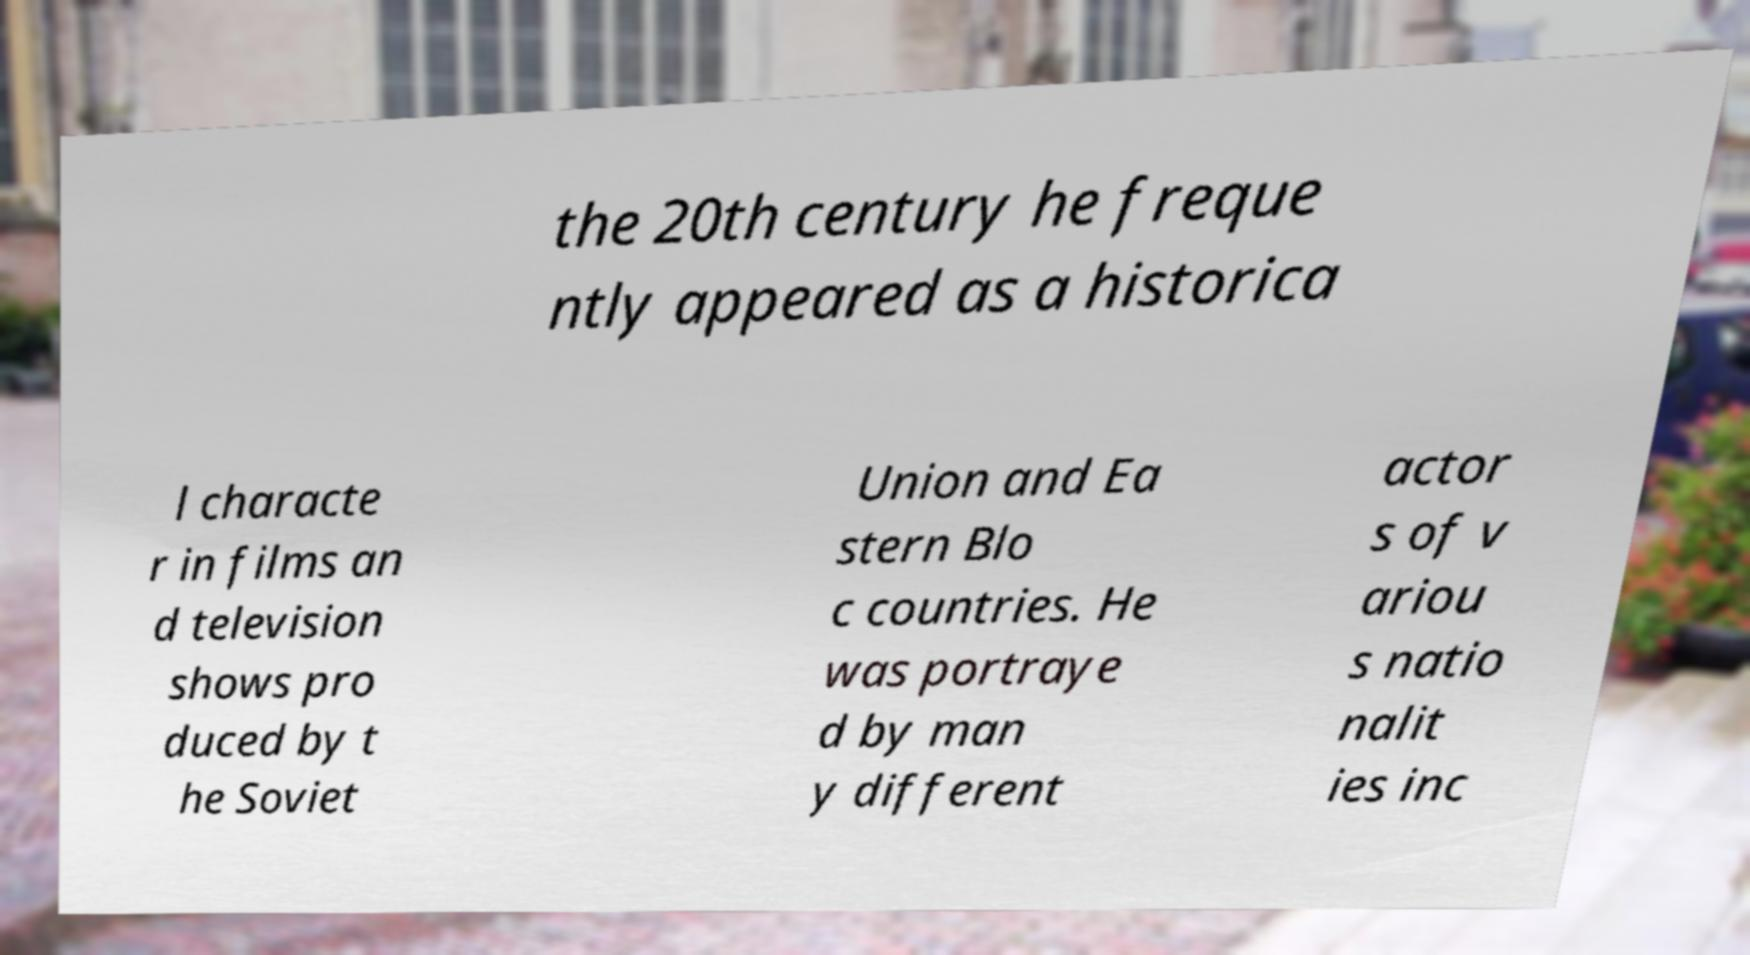Could you assist in decoding the text presented in this image and type it out clearly? the 20th century he freque ntly appeared as a historica l characte r in films an d television shows pro duced by t he Soviet Union and Ea stern Blo c countries. He was portraye d by man y different actor s of v ariou s natio nalit ies inc 